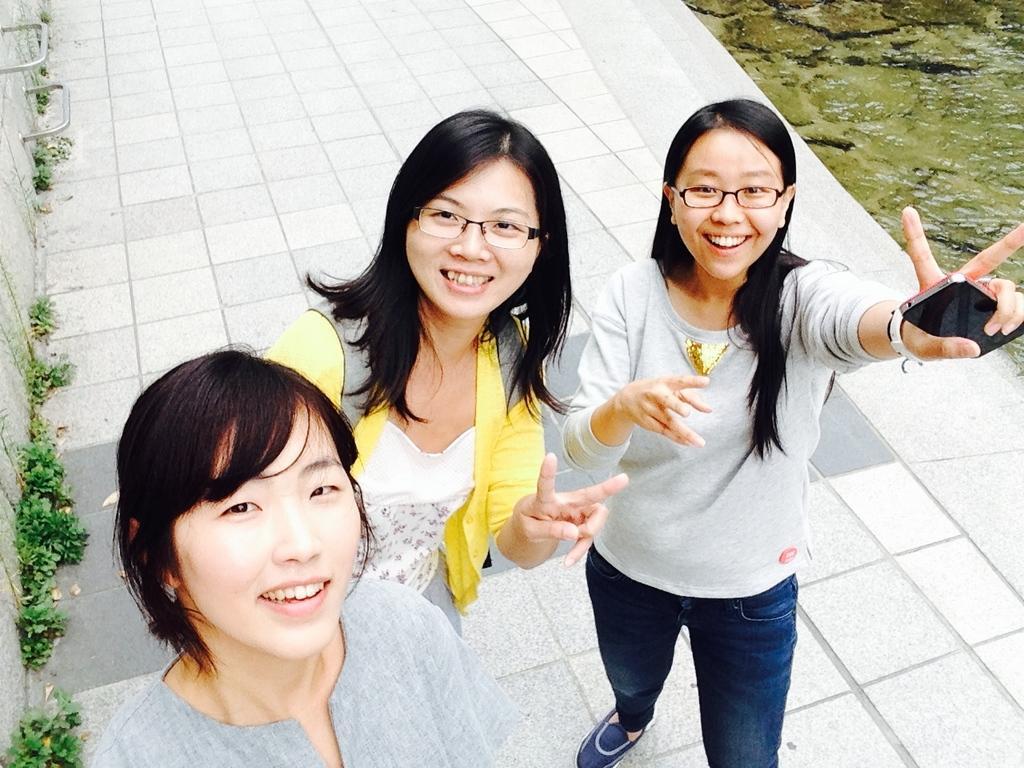Describe this image in one or two sentences. Here we can see three persons posing to a camera. They are smiling and they have spectacles. Here we can see plants. 